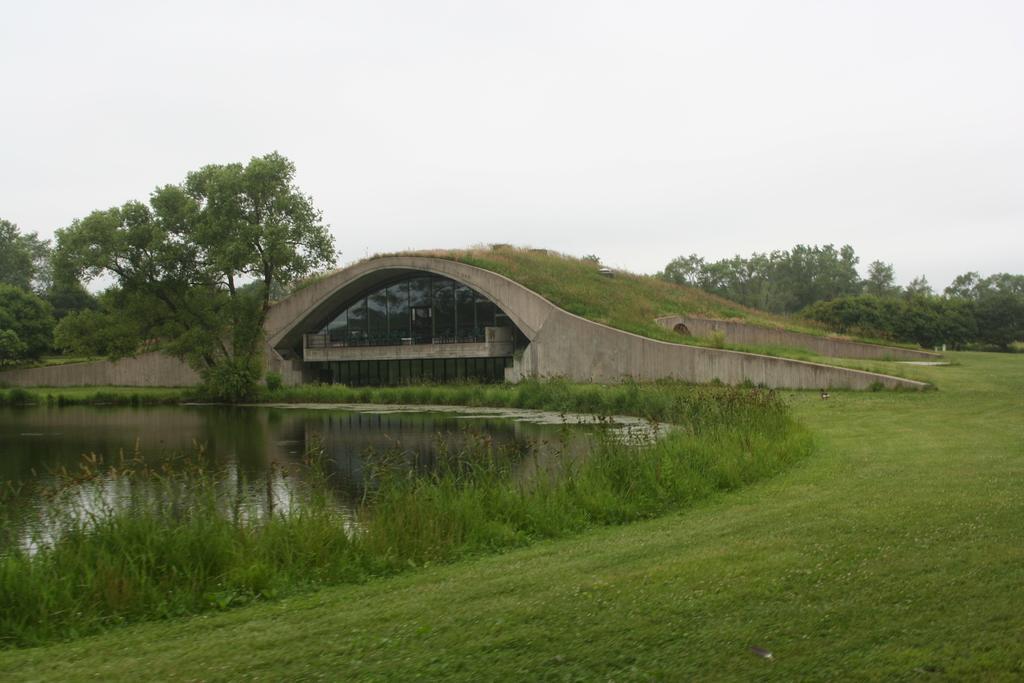Can you describe this image briefly? At the bottom of the picture, we see the grass. On the left side, we see water and this water might be in the pond. In the middle of the picture, we see trees and an arch bridge. There are trees in the background. At the top of the picture, we see the sky. 